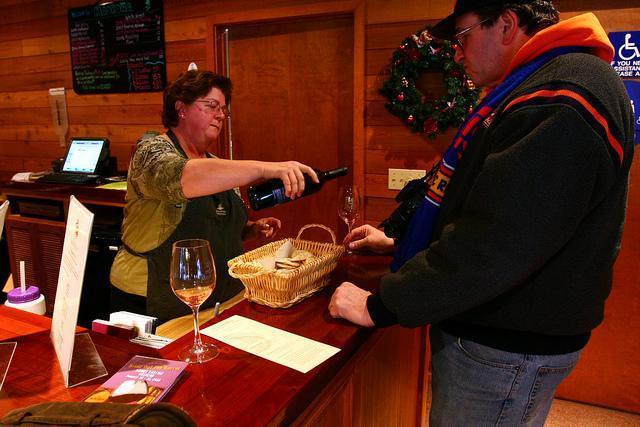How many people are there?
Give a very brief answer. 2. How many people can be seen?
Give a very brief answer. 2. How many birds are there?
Give a very brief answer. 0. 